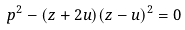Convert formula to latex. <formula><loc_0><loc_0><loc_500><loc_500>p ^ { 2 } - ( z + 2 u ) ( z - u ) ^ { 2 } = 0</formula> 